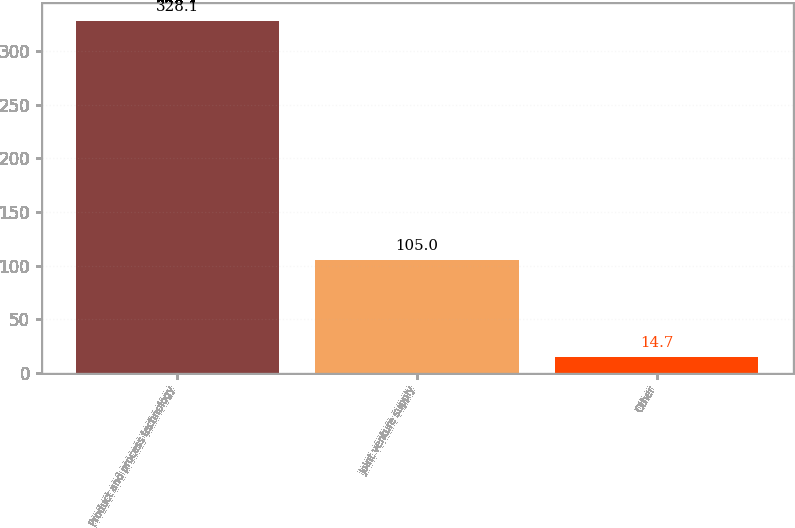Convert chart. <chart><loc_0><loc_0><loc_500><loc_500><bar_chart><fcel>Product and process technology<fcel>Joint venture supply<fcel>Other<nl><fcel>328.1<fcel>105<fcel>14.7<nl></chart> 